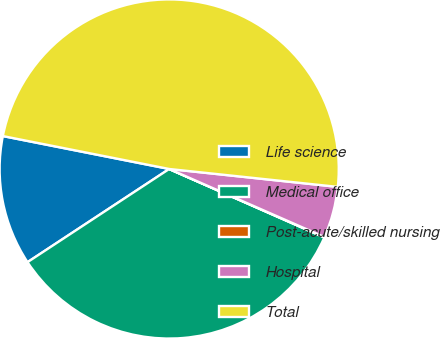<chart> <loc_0><loc_0><loc_500><loc_500><pie_chart><fcel>Life science<fcel>Medical office<fcel>Post-acute/skilled nursing<fcel>Hospital<fcel>Total<nl><fcel>12.37%<fcel>34.13%<fcel>0.04%<fcel>4.89%<fcel>48.58%<nl></chart> 